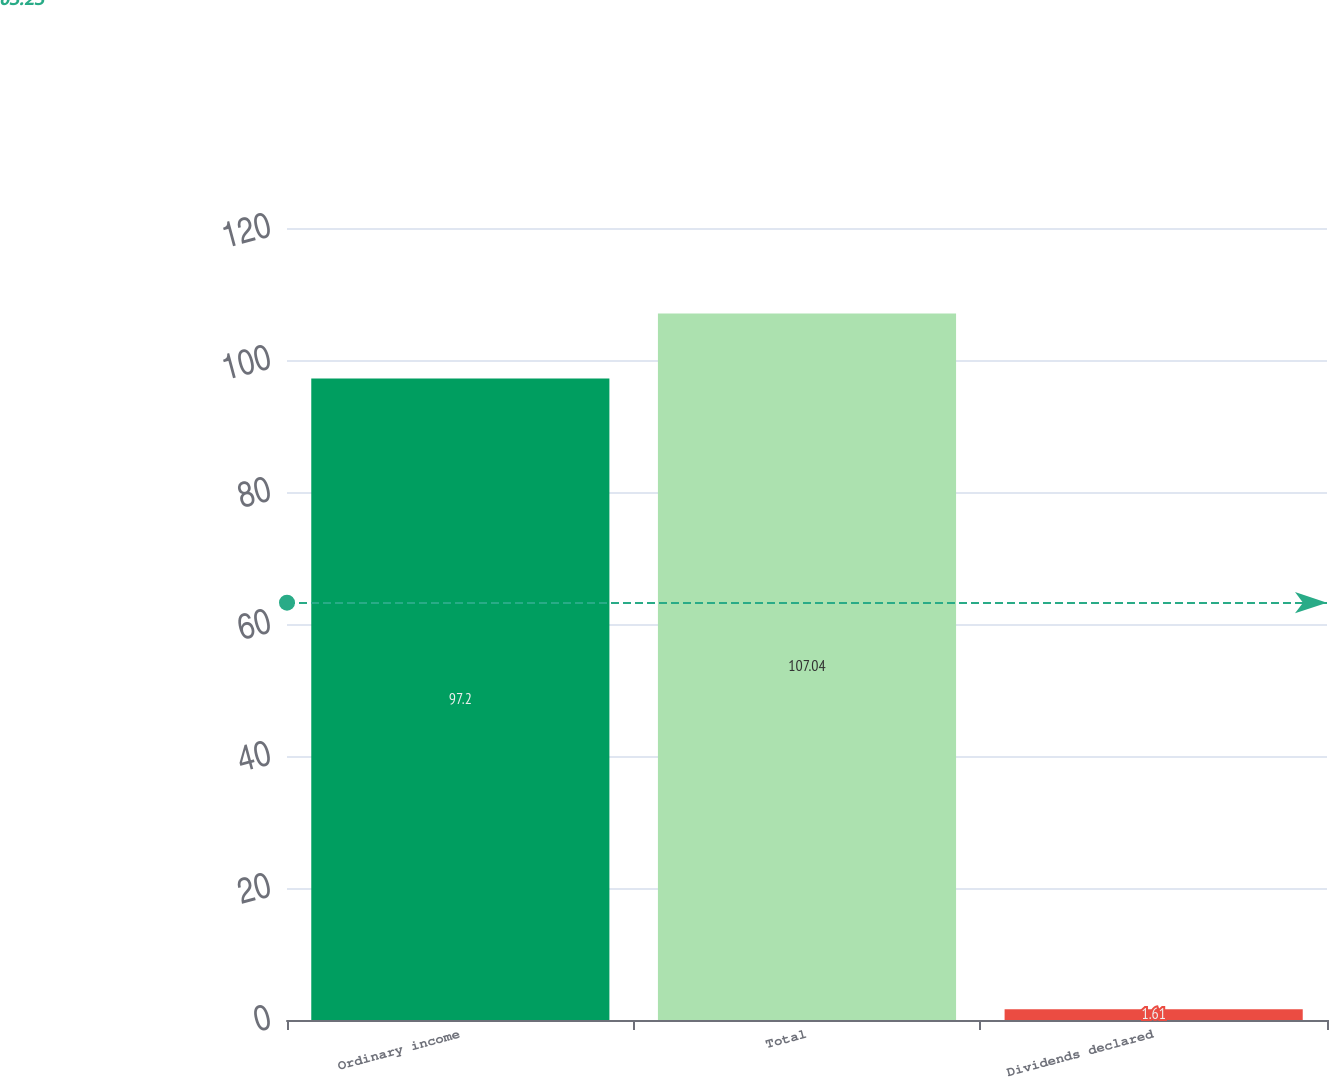Convert chart. <chart><loc_0><loc_0><loc_500><loc_500><bar_chart><fcel>Ordinary income<fcel>Total<fcel>Dividends declared<nl><fcel>97.2<fcel>107.04<fcel>1.61<nl></chart> 